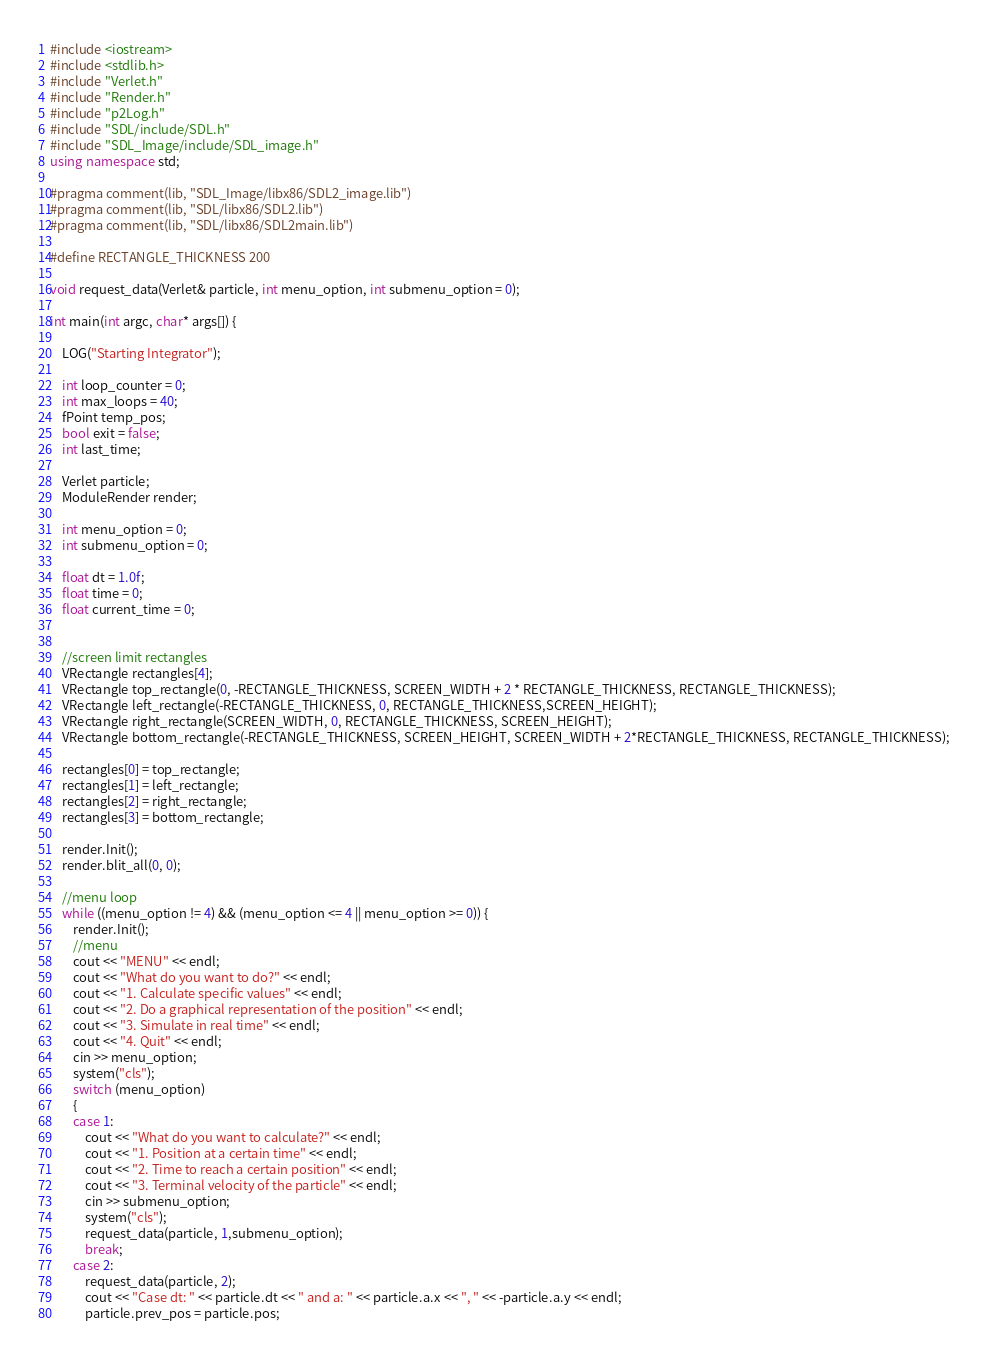<code> <loc_0><loc_0><loc_500><loc_500><_C++_>#include <iostream>
#include <stdlib.h>
#include "Verlet.h"
#include "Render.h"
#include "p2Log.h"
#include "SDL/include/SDL.h"
#include "SDL_Image/include/SDL_image.h"
using namespace std;

#pragma comment(lib, "SDL_Image/libx86/SDL2_image.lib")
#pragma comment(lib, "SDL/libx86/SDL2.lib")
#pragma comment(lib, "SDL/libx86/SDL2main.lib")

#define RECTANGLE_THICKNESS 200

void request_data(Verlet& particle, int menu_option, int submenu_option = 0);

int main(int argc, char* args[]) {

	LOG("Starting Integrator");

	int loop_counter = 0;
	int max_loops = 40;
	fPoint temp_pos;
	bool exit = false;
	int last_time;

	Verlet particle;
	ModuleRender render;

	int menu_option = 0;
	int submenu_option = 0;

	float dt = 1.0f;
	float time = 0;
	float current_time = 0;


	//screen limit rectangles
	VRectangle rectangles[4];
	VRectangle top_rectangle(0, -RECTANGLE_THICKNESS, SCREEN_WIDTH + 2 * RECTANGLE_THICKNESS, RECTANGLE_THICKNESS);
	VRectangle left_rectangle(-RECTANGLE_THICKNESS, 0, RECTANGLE_THICKNESS,SCREEN_HEIGHT);
	VRectangle right_rectangle(SCREEN_WIDTH, 0, RECTANGLE_THICKNESS, SCREEN_HEIGHT);
	VRectangle bottom_rectangle(-RECTANGLE_THICKNESS, SCREEN_HEIGHT, SCREEN_WIDTH + 2*RECTANGLE_THICKNESS, RECTANGLE_THICKNESS);

	rectangles[0] = top_rectangle;
	rectangles[1] = left_rectangle;
	rectangles[2] = right_rectangle;
	rectangles[3] = bottom_rectangle;

	render.Init();
	render.blit_all(0, 0);

	//menu loop
	while ((menu_option != 4) && (menu_option <= 4 || menu_option >= 0)) {
		render.Init();
		//menu
		cout << "MENU" << endl;
		cout << "What do you want to do?" << endl;
		cout << "1. Calculate specific values" << endl;
		cout << "2. Do a graphical representation of the position" << endl;
		cout << "3. Simulate in real time" << endl;
		cout << "4. Quit" << endl;
		cin >> menu_option;
		system("cls");
		switch (menu_option)
		{
		case 1:
			cout << "What do you want to calculate?" << endl;
			cout << "1. Position at a certain time" << endl;
			cout << "2. Time to reach a certain position" << endl;
			cout << "3. Terminal velocity of the particle" << endl;
			cin >> submenu_option;
			system("cls");
			request_data(particle, 1,submenu_option);
			break;
		case 2:
			request_data(particle, 2);
			cout << "Case dt: " << particle.dt << " and a: " << particle.a.x << ", " << -particle.a.y << endl;
			particle.prev_pos = particle.pos;
</code> 